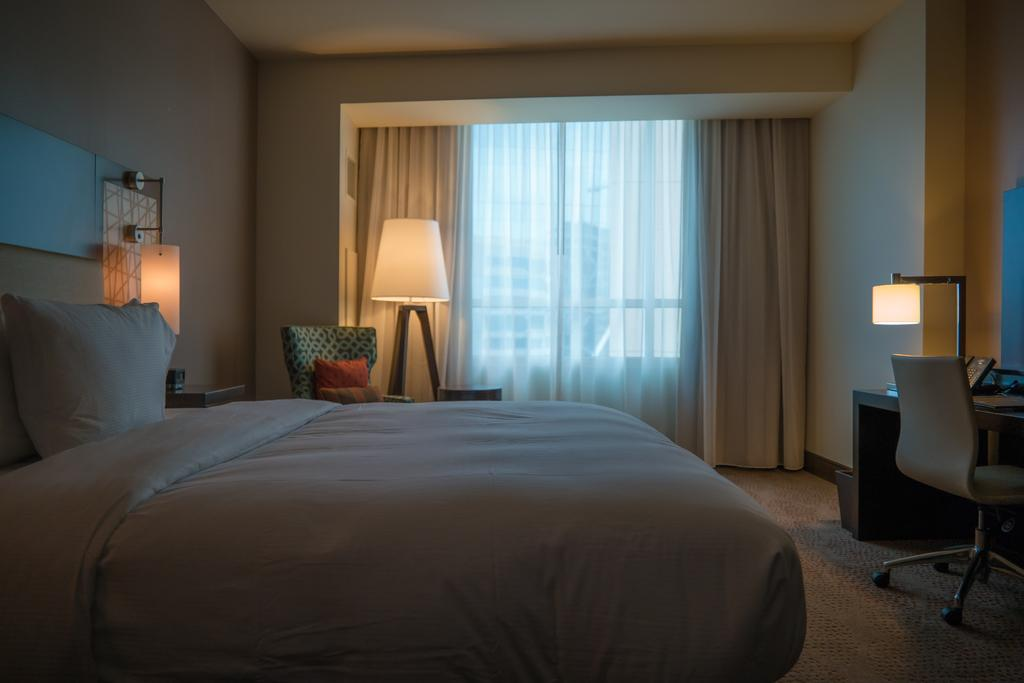What type of space is shown in the image? The image is an inside picture of a room. What furniture is present in the room? There is a bed, lamps, chairs, and a table with objects on it in the room. What can be found on the bed? There are pillows on the bed. What type of window treatment is present in the room? There are curtains in the room. What part of the room's structure is visible? The wall is visible in the room. What type of comb is used by the father in the image? There is no father or comb present in the image. 